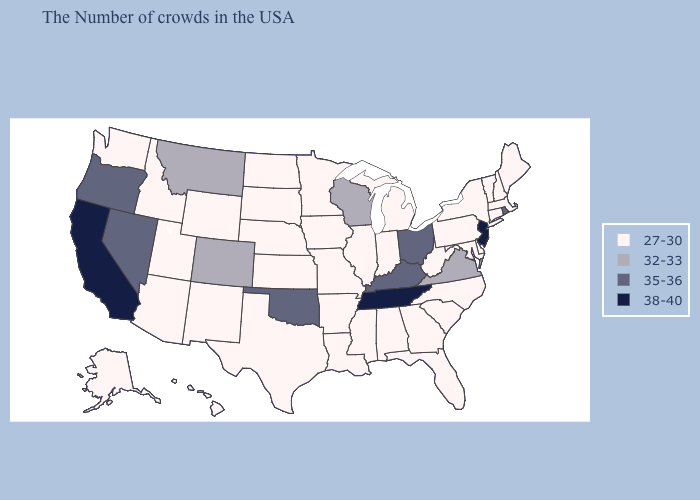Does Tennessee have a lower value than Oklahoma?
Short answer required. No. What is the value of Michigan?
Answer briefly. 27-30. Does the first symbol in the legend represent the smallest category?
Concise answer only. Yes. Which states have the highest value in the USA?
Short answer required. New Jersey, Tennessee, California. Name the states that have a value in the range 38-40?
Keep it brief. New Jersey, Tennessee, California. What is the highest value in the MidWest ?
Concise answer only. 35-36. Name the states that have a value in the range 32-33?
Answer briefly. Virginia, Wisconsin, Colorado, Montana. What is the highest value in the Northeast ?
Keep it brief. 38-40. What is the value of Alabama?
Quick response, please. 27-30. What is the lowest value in states that border New York?
Be succinct. 27-30. Which states have the highest value in the USA?
Be succinct. New Jersey, Tennessee, California. Does New Jersey have the lowest value in the USA?
Quick response, please. No. Name the states that have a value in the range 38-40?
Quick response, please. New Jersey, Tennessee, California. Which states have the highest value in the USA?
Give a very brief answer. New Jersey, Tennessee, California. What is the highest value in the USA?
Short answer required. 38-40. 